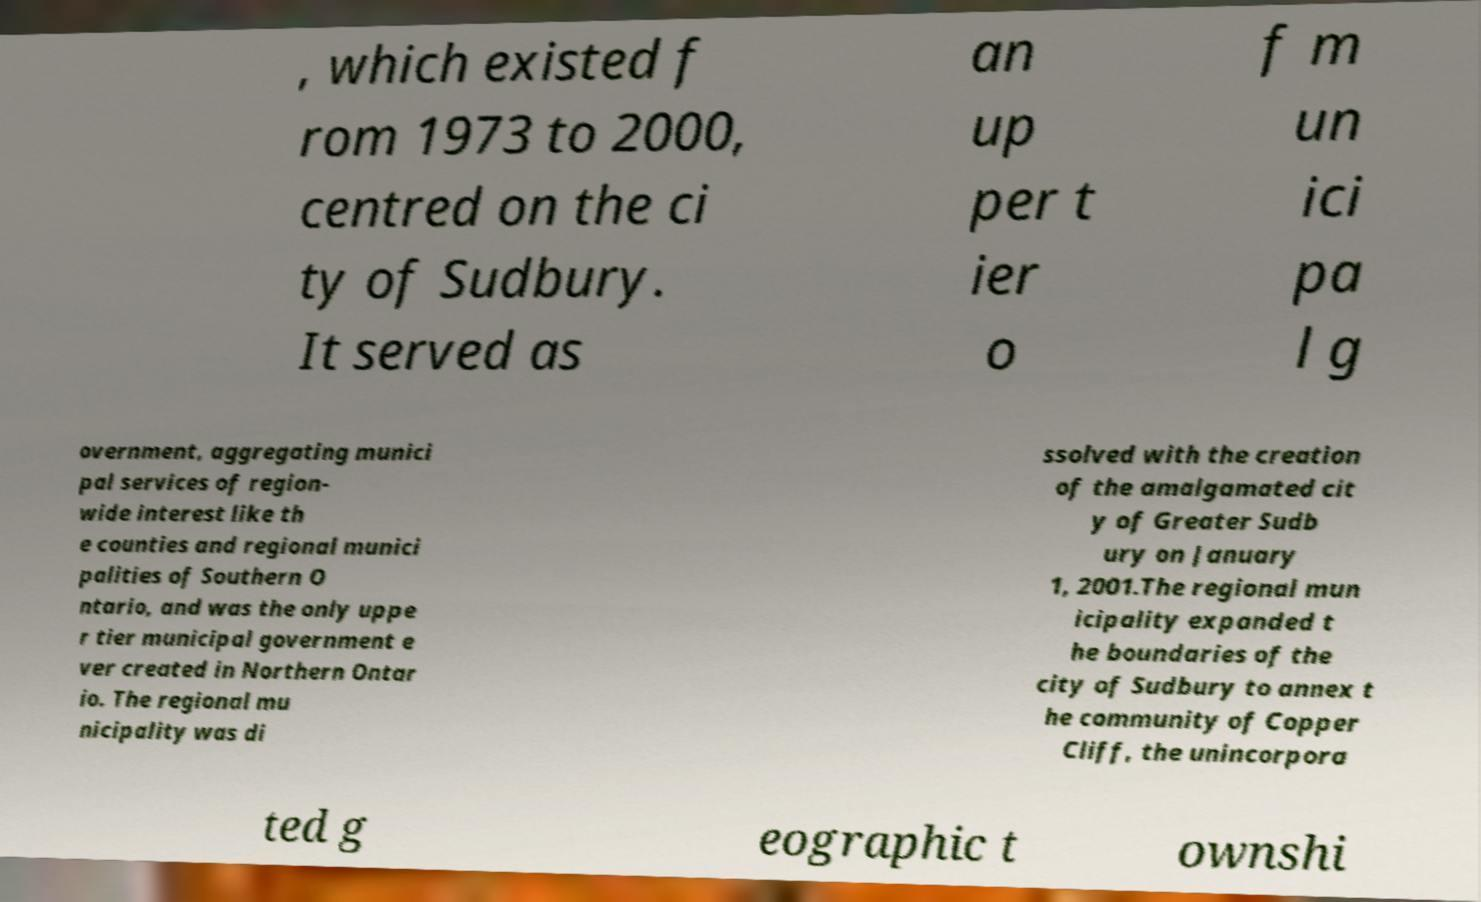For documentation purposes, I need the text within this image transcribed. Could you provide that? , which existed f rom 1973 to 2000, centred on the ci ty of Sudbury. It served as an up per t ier o f m un ici pa l g overnment, aggregating munici pal services of region- wide interest like th e counties and regional munici palities of Southern O ntario, and was the only uppe r tier municipal government e ver created in Northern Ontar io. The regional mu nicipality was di ssolved with the creation of the amalgamated cit y of Greater Sudb ury on January 1, 2001.The regional mun icipality expanded t he boundaries of the city of Sudbury to annex t he community of Copper Cliff, the unincorpora ted g eographic t ownshi 